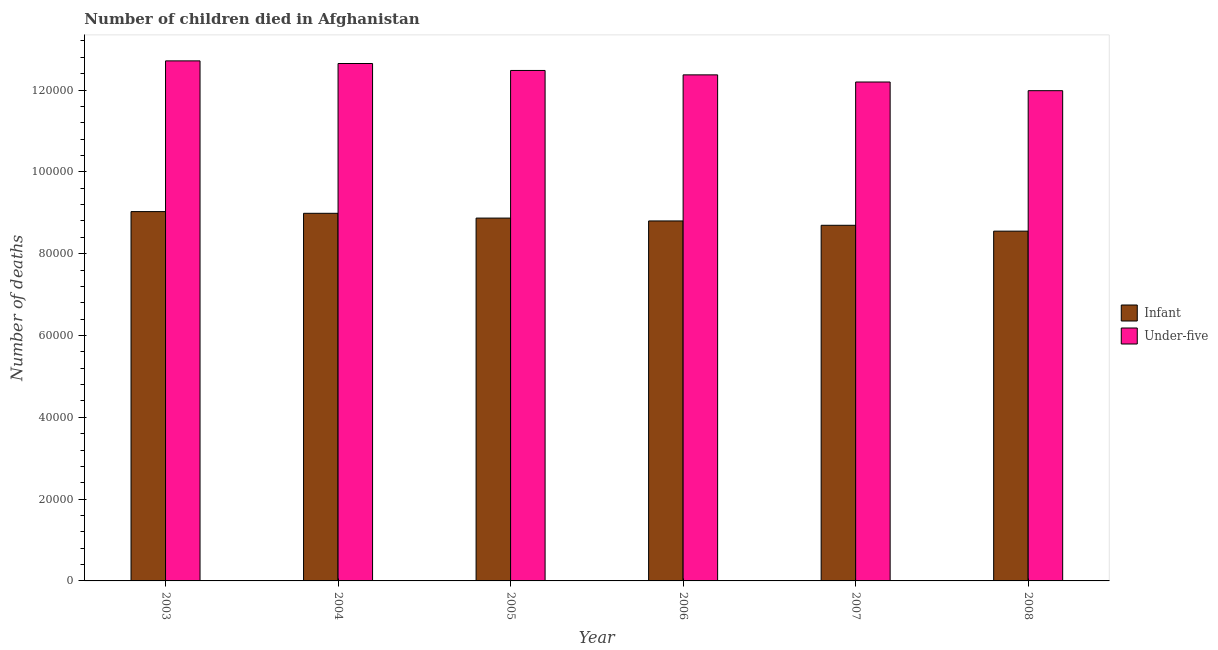How many groups of bars are there?
Keep it short and to the point. 6. How many bars are there on the 5th tick from the left?
Provide a succinct answer. 2. How many bars are there on the 1st tick from the right?
Make the answer very short. 2. What is the label of the 5th group of bars from the left?
Your answer should be very brief. 2007. What is the number of infant deaths in 2008?
Offer a terse response. 8.55e+04. Across all years, what is the maximum number of infant deaths?
Make the answer very short. 9.03e+04. Across all years, what is the minimum number of under-five deaths?
Your answer should be compact. 1.20e+05. In which year was the number of infant deaths maximum?
Your response must be concise. 2003. What is the total number of under-five deaths in the graph?
Give a very brief answer. 7.44e+05. What is the difference between the number of under-five deaths in 2007 and that in 2008?
Your answer should be very brief. 2118. What is the difference between the number of under-five deaths in 2006 and the number of infant deaths in 2004?
Your answer should be compact. -2777. What is the average number of infant deaths per year?
Make the answer very short. 8.82e+04. What is the ratio of the number of under-five deaths in 2004 to that in 2007?
Offer a very short reply. 1.04. Is the number of under-five deaths in 2003 less than that in 2006?
Your answer should be very brief. No. Is the difference between the number of under-five deaths in 2003 and 2007 greater than the difference between the number of infant deaths in 2003 and 2007?
Offer a very short reply. No. What is the difference between the highest and the second highest number of under-five deaths?
Ensure brevity in your answer.  643. What is the difference between the highest and the lowest number of infant deaths?
Provide a succinct answer. 4779. Is the sum of the number of under-five deaths in 2006 and 2008 greater than the maximum number of infant deaths across all years?
Provide a succinct answer. Yes. What does the 1st bar from the left in 2003 represents?
Offer a terse response. Infant. What does the 1st bar from the right in 2004 represents?
Keep it short and to the point. Under-five. How many bars are there?
Your response must be concise. 12. Are all the bars in the graph horizontal?
Ensure brevity in your answer.  No. How many years are there in the graph?
Keep it short and to the point. 6. Does the graph contain any zero values?
Offer a very short reply. No. Where does the legend appear in the graph?
Your answer should be compact. Center right. What is the title of the graph?
Your answer should be very brief. Number of children died in Afghanistan. What is the label or title of the Y-axis?
Provide a short and direct response. Number of deaths. What is the Number of deaths in Infant in 2003?
Your answer should be compact. 9.03e+04. What is the Number of deaths of Under-five in 2003?
Provide a succinct answer. 1.27e+05. What is the Number of deaths in Infant in 2004?
Provide a short and direct response. 8.99e+04. What is the Number of deaths of Under-five in 2004?
Provide a succinct answer. 1.26e+05. What is the Number of deaths of Infant in 2005?
Give a very brief answer. 8.87e+04. What is the Number of deaths of Under-five in 2005?
Offer a terse response. 1.25e+05. What is the Number of deaths in Infant in 2006?
Provide a short and direct response. 8.80e+04. What is the Number of deaths of Under-five in 2006?
Your answer should be compact. 1.24e+05. What is the Number of deaths of Infant in 2007?
Your answer should be very brief. 8.69e+04. What is the Number of deaths in Under-five in 2007?
Provide a succinct answer. 1.22e+05. What is the Number of deaths in Infant in 2008?
Make the answer very short. 8.55e+04. What is the Number of deaths of Under-five in 2008?
Keep it short and to the point. 1.20e+05. Across all years, what is the maximum Number of deaths of Infant?
Provide a succinct answer. 9.03e+04. Across all years, what is the maximum Number of deaths of Under-five?
Provide a succinct answer. 1.27e+05. Across all years, what is the minimum Number of deaths in Infant?
Your response must be concise. 8.55e+04. Across all years, what is the minimum Number of deaths in Under-five?
Provide a short and direct response. 1.20e+05. What is the total Number of deaths of Infant in the graph?
Ensure brevity in your answer.  5.29e+05. What is the total Number of deaths of Under-five in the graph?
Offer a terse response. 7.44e+05. What is the difference between the Number of deaths of Infant in 2003 and that in 2004?
Give a very brief answer. 419. What is the difference between the Number of deaths of Under-five in 2003 and that in 2004?
Offer a terse response. 643. What is the difference between the Number of deaths of Infant in 2003 and that in 2005?
Offer a very short reply. 1588. What is the difference between the Number of deaths in Under-five in 2003 and that in 2005?
Your response must be concise. 2342. What is the difference between the Number of deaths in Infant in 2003 and that in 2006?
Offer a very short reply. 2285. What is the difference between the Number of deaths of Under-five in 2003 and that in 2006?
Provide a short and direct response. 3420. What is the difference between the Number of deaths of Infant in 2003 and that in 2007?
Provide a short and direct response. 3347. What is the difference between the Number of deaths of Under-five in 2003 and that in 2007?
Make the answer very short. 5167. What is the difference between the Number of deaths in Infant in 2003 and that in 2008?
Ensure brevity in your answer.  4779. What is the difference between the Number of deaths of Under-five in 2003 and that in 2008?
Provide a short and direct response. 7285. What is the difference between the Number of deaths of Infant in 2004 and that in 2005?
Provide a short and direct response. 1169. What is the difference between the Number of deaths of Under-five in 2004 and that in 2005?
Your answer should be very brief. 1699. What is the difference between the Number of deaths in Infant in 2004 and that in 2006?
Your answer should be compact. 1866. What is the difference between the Number of deaths in Under-five in 2004 and that in 2006?
Keep it short and to the point. 2777. What is the difference between the Number of deaths in Infant in 2004 and that in 2007?
Ensure brevity in your answer.  2928. What is the difference between the Number of deaths in Under-five in 2004 and that in 2007?
Make the answer very short. 4524. What is the difference between the Number of deaths of Infant in 2004 and that in 2008?
Provide a succinct answer. 4360. What is the difference between the Number of deaths of Under-five in 2004 and that in 2008?
Your answer should be very brief. 6642. What is the difference between the Number of deaths of Infant in 2005 and that in 2006?
Give a very brief answer. 697. What is the difference between the Number of deaths of Under-five in 2005 and that in 2006?
Offer a very short reply. 1078. What is the difference between the Number of deaths in Infant in 2005 and that in 2007?
Give a very brief answer. 1759. What is the difference between the Number of deaths in Under-five in 2005 and that in 2007?
Your response must be concise. 2825. What is the difference between the Number of deaths of Infant in 2005 and that in 2008?
Provide a succinct answer. 3191. What is the difference between the Number of deaths in Under-five in 2005 and that in 2008?
Make the answer very short. 4943. What is the difference between the Number of deaths in Infant in 2006 and that in 2007?
Keep it short and to the point. 1062. What is the difference between the Number of deaths of Under-five in 2006 and that in 2007?
Keep it short and to the point. 1747. What is the difference between the Number of deaths in Infant in 2006 and that in 2008?
Offer a very short reply. 2494. What is the difference between the Number of deaths of Under-five in 2006 and that in 2008?
Keep it short and to the point. 3865. What is the difference between the Number of deaths of Infant in 2007 and that in 2008?
Your answer should be very brief. 1432. What is the difference between the Number of deaths in Under-five in 2007 and that in 2008?
Your response must be concise. 2118. What is the difference between the Number of deaths of Infant in 2003 and the Number of deaths of Under-five in 2004?
Make the answer very short. -3.62e+04. What is the difference between the Number of deaths in Infant in 2003 and the Number of deaths in Under-five in 2005?
Keep it short and to the point. -3.45e+04. What is the difference between the Number of deaths of Infant in 2003 and the Number of deaths of Under-five in 2006?
Offer a very short reply. -3.34e+04. What is the difference between the Number of deaths in Infant in 2003 and the Number of deaths in Under-five in 2007?
Keep it short and to the point. -3.17e+04. What is the difference between the Number of deaths of Infant in 2003 and the Number of deaths of Under-five in 2008?
Your response must be concise. -2.96e+04. What is the difference between the Number of deaths of Infant in 2004 and the Number of deaths of Under-five in 2005?
Offer a very short reply. -3.49e+04. What is the difference between the Number of deaths of Infant in 2004 and the Number of deaths of Under-five in 2006?
Provide a short and direct response. -3.38e+04. What is the difference between the Number of deaths in Infant in 2004 and the Number of deaths in Under-five in 2007?
Give a very brief answer. -3.21e+04. What is the difference between the Number of deaths of Infant in 2004 and the Number of deaths of Under-five in 2008?
Make the answer very short. -3.00e+04. What is the difference between the Number of deaths in Infant in 2005 and the Number of deaths in Under-five in 2006?
Offer a terse response. -3.50e+04. What is the difference between the Number of deaths of Infant in 2005 and the Number of deaths of Under-five in 2007?
Provide a short and direct response. -3.33e+04. What is the difference between the Number of deaths of Infant in 2005 and the Number of deaths of Under-five in 2008?
Keep it short and to the point. -3.12e+04. What is the difference between the Number of deaths of Infant in 2006 and the Number of deaths of Under-five in 2007?
Make the answer very short. -3.40e+04. What is the difference between the Number of deaths of Infant in 2006 and the Number of deaths of Under-five in 2008?
Your answer should be compact. -3.18e+04. What is the difference between the Number of deaths in Infant in 2007 and the Number of deaths in Under-five in 2008?
Give a very brief answer. -3.29e+04. What is the average Number of deaths of Infant per year?
Provide a short and direct response. 8.82e+04. What is the average Number of deaths in Under-five per year?
Give a very brief answer. 1.24e+05. In the year 2003, what is the difference between the Number of deaths in Infant and Number of deaths in Under-five?
Provide a succinct answer. -3.68e+04. In the year 2004, what is the difference between the Number of deaths in Infant and Number of deaths in Under-five?
Make the answer very short. -3.66e+04. In the year 2005, what is the difference between the Number of deaths of Infant and Number of deaths of Under-five?
Ensure brevity in your answer.  -3.61e+04. In the year 2006, what is the difference between the Number of deaths in Infant and Number of deaths in Under-five?
Provide a succinct answer. -3.57e+04. In the year 2007, what is the difference between the Number of deaths of Infant and Number of deaths of Under-five?
Offer a very short reply. -3.50e+04. In the year 2008, what is the difference between the Number of deaths of Infant and Number of deaths of Under-five?
Your answer should be compact. -3.43e+04. What is the ratio of the Number of deaths of Infant in 2003 to that in 2005?
Give a very brief answer. 1.02. What is the ratio of the Number of deaths in Under-five in 2003 to that in 2005?
Make the answer very short. 1.02. What is the ratio of the Number of deaths in Under-five in 2003 to that in 2006?
Make the answer very short. 1.03. What is the ratio of the Number of deaths in Under-five in 2003 to that in 2007?
Offer a terse response. 1.04. What is the ratio of the Number of deaths in Infant in 2003 to that in 2008?
Your answer should be compact. 1.06. What is the ratio of the Number of deaths of Under-five in 2003 to that in 2008?
Provide a succinct answer. 1.06. What is the ratio of the Number of deaths in Infant in 2004 to that in 2005?
Give a very brief answer. 1.01. What is the ratio of the Number of deaths in Under-five in 2004 to that in 2005?
Keep it short and to the point. 1.01. What is the ratio of the Number of deaths of Infant in 2004 to that in 2006?
Provide a succinct answer. 1.02. What is the ratio of the Number of deaths in Under-five in 2004 to that in 2006?
Your response must be concise. 1.02. What is the ratio of the Number of deaths in Infant in 2004 to that in 2007?
Your answer should be very brief. 1.03. What is the ratio of the Number of deaths of Under-five in 2004 to that in 2007?
Provide a short and direct response. 1.04. What is the ratio of the Number of deaths in Infant in 2004 to that in 2008?
Provide a succinct answer. 1.05. What is the ratio of the Number of deaths of Under-five in 2004 to that in 2008?
Give a very brief answer. 1.06. What is the ratio of the Number of deaths of Infant in 2005 to that in 2006?
Give a very brief answer. 1.01. What is the ratio of the Number of deaths of Under-five in 2005 to that in 2006?
Provide a succinct answer. 1.01. What is the ratio of the Number of deaths in Infant in 2005 to that in 2007?
Keep it short and to the point. 1.02. What is the ratio of the Number of deaths of Under-five in 2005 to that in 2007?
Keep it short and to the point. 1.02. What is the ratio of the Number of deaths in Infant in 2005 to that in 2008?
Provide a succinct answer. 1.04. What is the ratio of the Number of deaths in Under-five in 2005 to that in 2008?
Your answer should be compact. 1.04. What is the ratio of the Number of deaths in Infant in 2006 to that in 2007?
Provide a short and direct response. 1.01. What is the ratio of the Number of deaths of Under-five in 2006 to that in 2007?
Your response must be concise. 1.01. What is the ratio of the Number of deaths in Infant in 2006 to that in 2008?
Your response must be concise. 1.03. What is the ratio of the Number of deaths of Under-five in 2006 to that in 2008?
Your answer should be compact. 1.03. What is the ratio of the Number of deaths of Infant in 2007 to that in 2008?
Make the answer very short. 1.02. What is the ratio of the Number of deaths in Under-five in 2007 to that in 2008?
Provide a succinct answer. 1.02. What is the difference between the highest and the second highest Number of deaths of Infant?
Your answer should be very brief. 419. What is the difference between the highest and the second highest Number of deaths in Under-five?
Make the answer very short. 643. What is the difference between the highest and the lowest Number of deaths in Infant?
Provide a short and direct response. 4779. What is the difference between the highest and the lowest Number of deaths in Under-five?
Ensure brevity in your answer.  7285. 